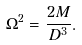<formula> <loc_0><loc_0><loc_500><loc_500>\Omega ^ { 2 } = \frac { 2 M } { D ^ { 3 } } .</formula> 